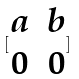<formula> <loc_0><loc_0><loc_500><loc_500>[ \begin{matrix} a & b \\ 0 & 0 \end{matrix} ]</formula> 